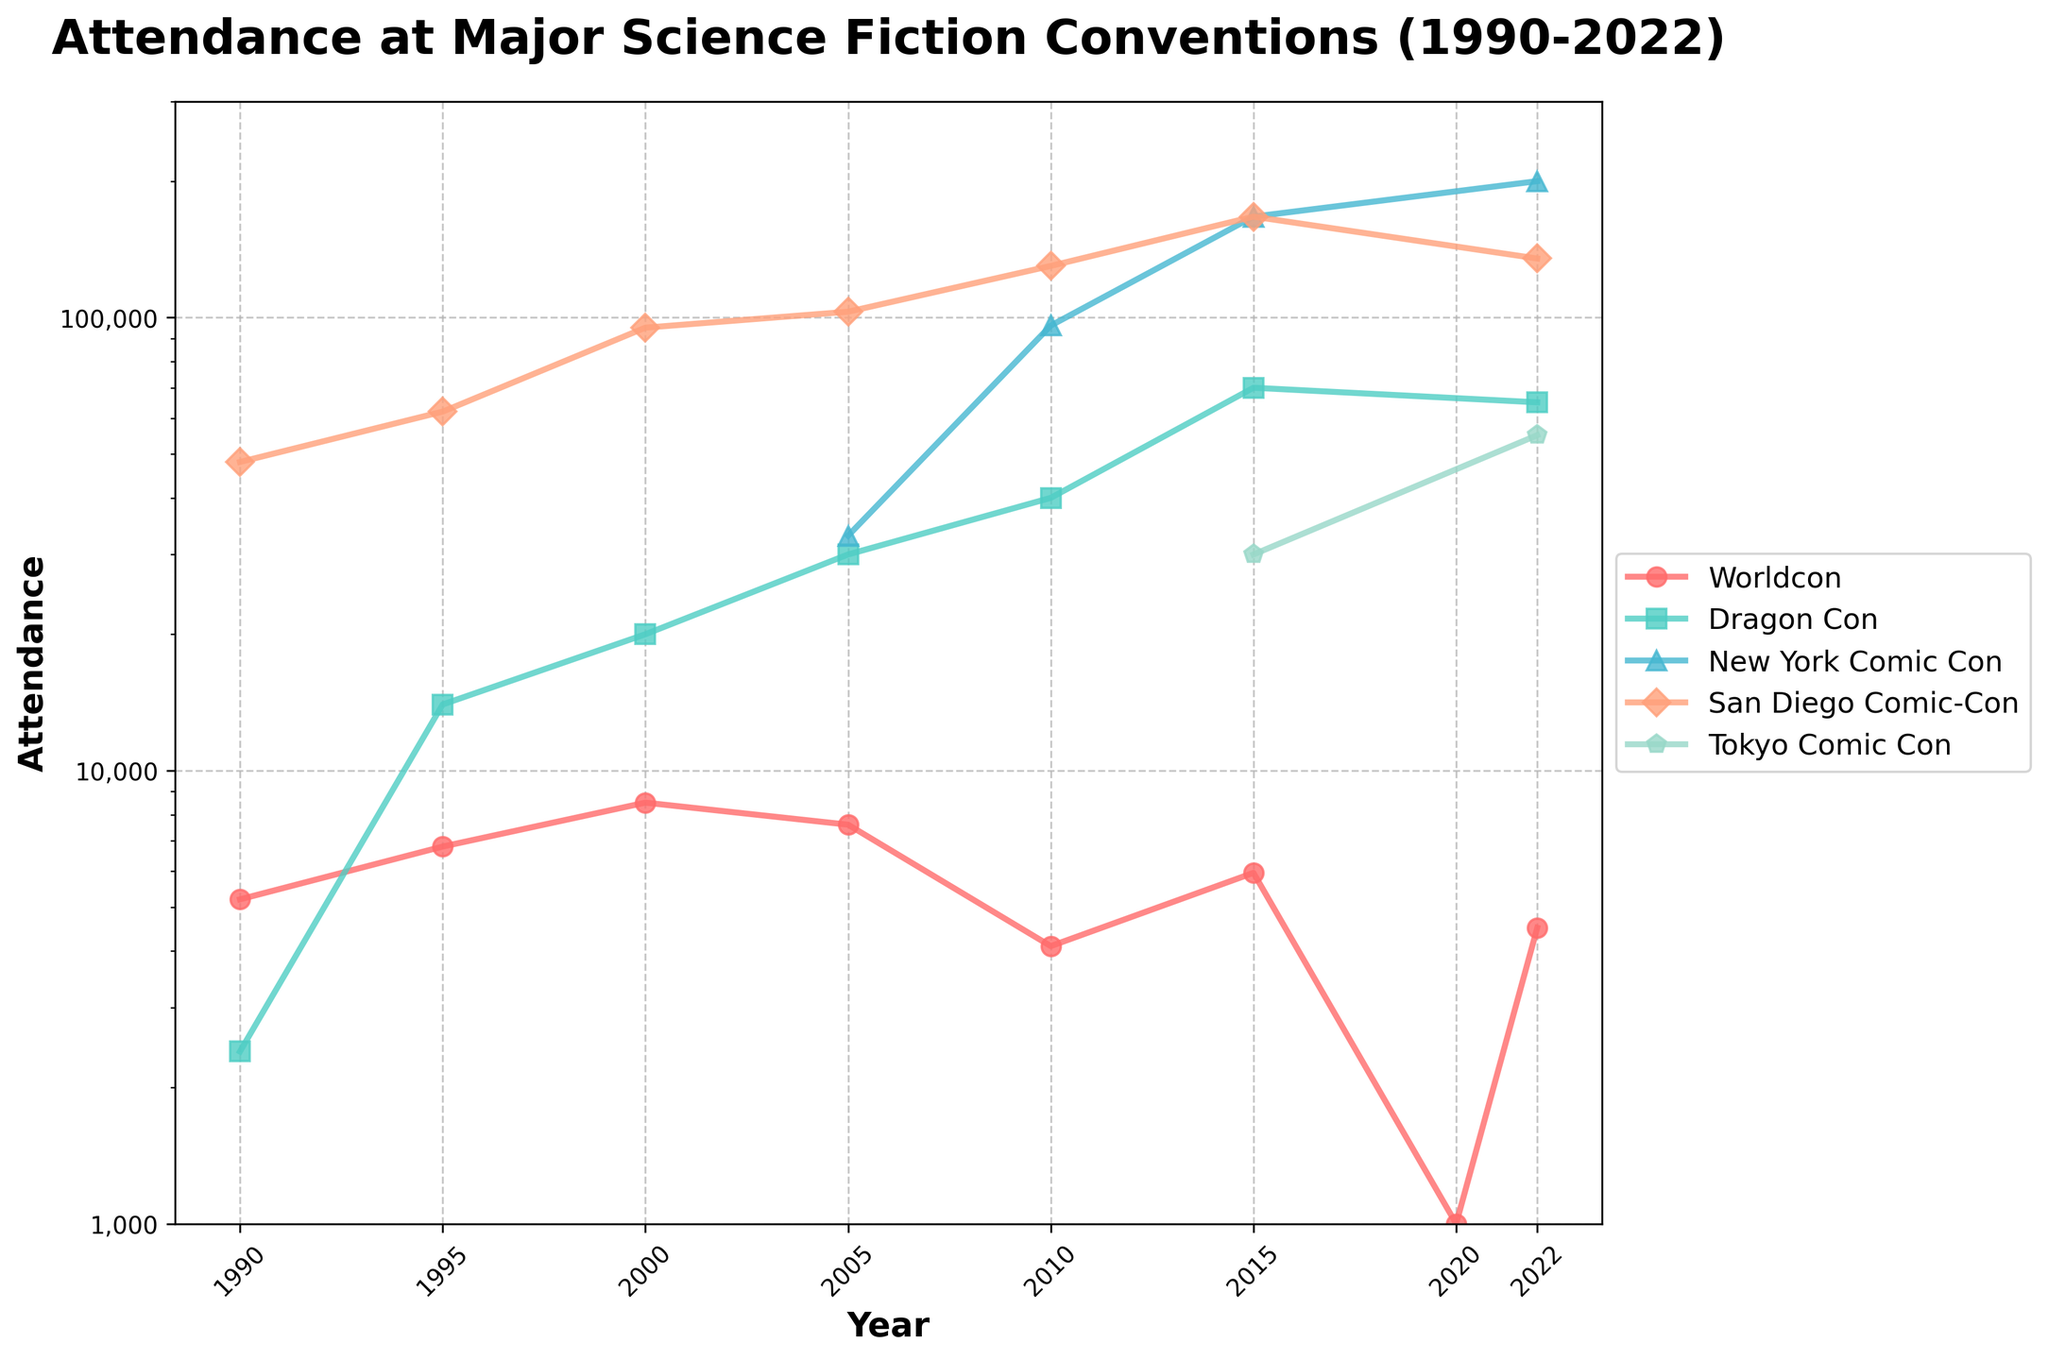Where was the highest peak in attendance for San Diego Comic-Con and in which year? San Diego Comic-Con's curve peaks in 2015, reaching 167,000 attendees. This is the highest peak for San Diego Comic-Con in the plotted period.
Answer: 2015, 167,000 Which convention had the highest attendance in 2022 and what was the value? In 2022, New York Comic Con’s curve is the highest among all conventions, showing an attendance of 200,000.
Answer: New York Comic Con, 200,000 How did Worldcon's attendance change from 2010 to 2015? In 2010, Worldcon's attendance was 4,100, which increased to 5,950 in 2015. The difference is 5,950 - 4,100 = 1,850.
Answer: Increased by 1,850 Which two conventions had a significant decrease in attendance from 2019 to 2020? Worldcon is the only convention with data available for both years, dropping significantly from 5,950 in 2015 to 1,000 in 2020.
Answer: Worldcon Compare the attendance of Dragon Con to Tokyo Comic Con in 2022. Which one is higher and by how much? In 2022, Dragon Con had 65,000 attendees, while Tokyo Comic Con had 55,000 attendees. So, Dragon Con's attendance is higher by 65,000 - 55,000 = 10,000.
Answer: Dragon Con by 10,000 What is the average attendance of New York Comic Con from 2005 to 2022? The attendance figures for New York Comic Con are available for 2005 (33,000), 2010 (96,000), 2015 (167,000), and 2022 (200,000). Summing these gives 33,000 + 96,000 + 167,000 + 200,000 = 496,000. The total number of years with data is 4. Therefore, the average attendance is 496,000 / 4 = 124,000.
Answer: 124,000 Which convention has the most fluctuating attendance figures over the years? Worldcon shows the most fluctuation, with significant rises and falls in attendance. For example, it went from 8,500 in 2000 to 4,100 in 2010, then up to 5,950 in 2015, and down again to 1,000 in 2020.
Answer: Worldcon 